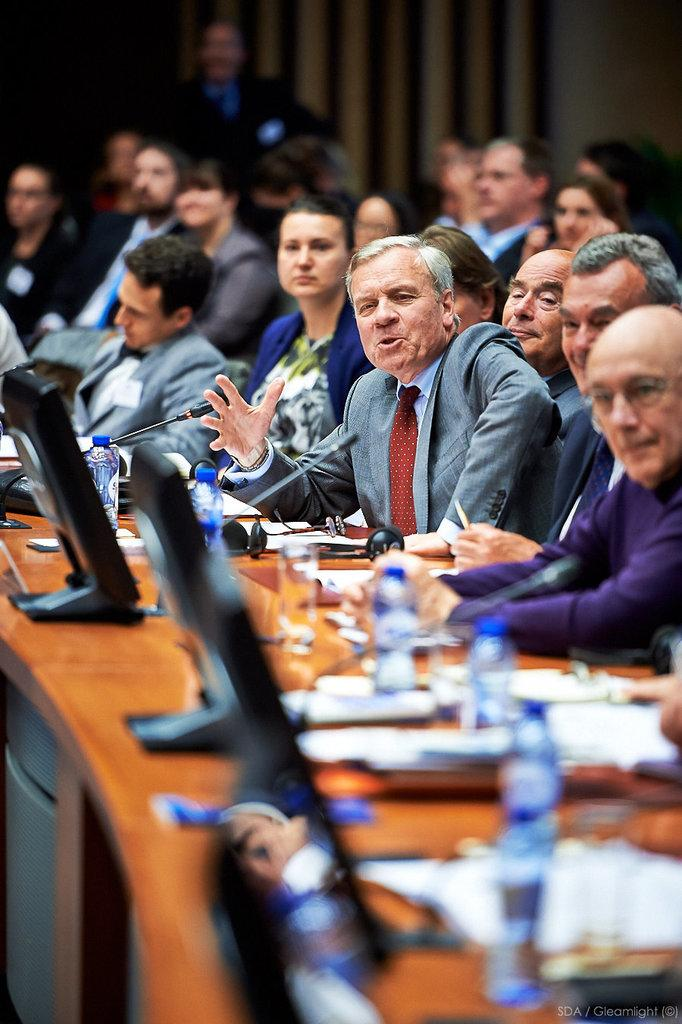What are the people in the image doing? People are seated in the image. What is on the table in the image? There is a table in the image with screens, bottles, glasses, papers, and headsets on it. What is the person at the center wearing? The person at the center is wearing a suit. How would you describe the background of the image? The background is blurred. What advice does the father give to the expert in the image? There is no father or expert present in the image, so no such interaction can be observed. 